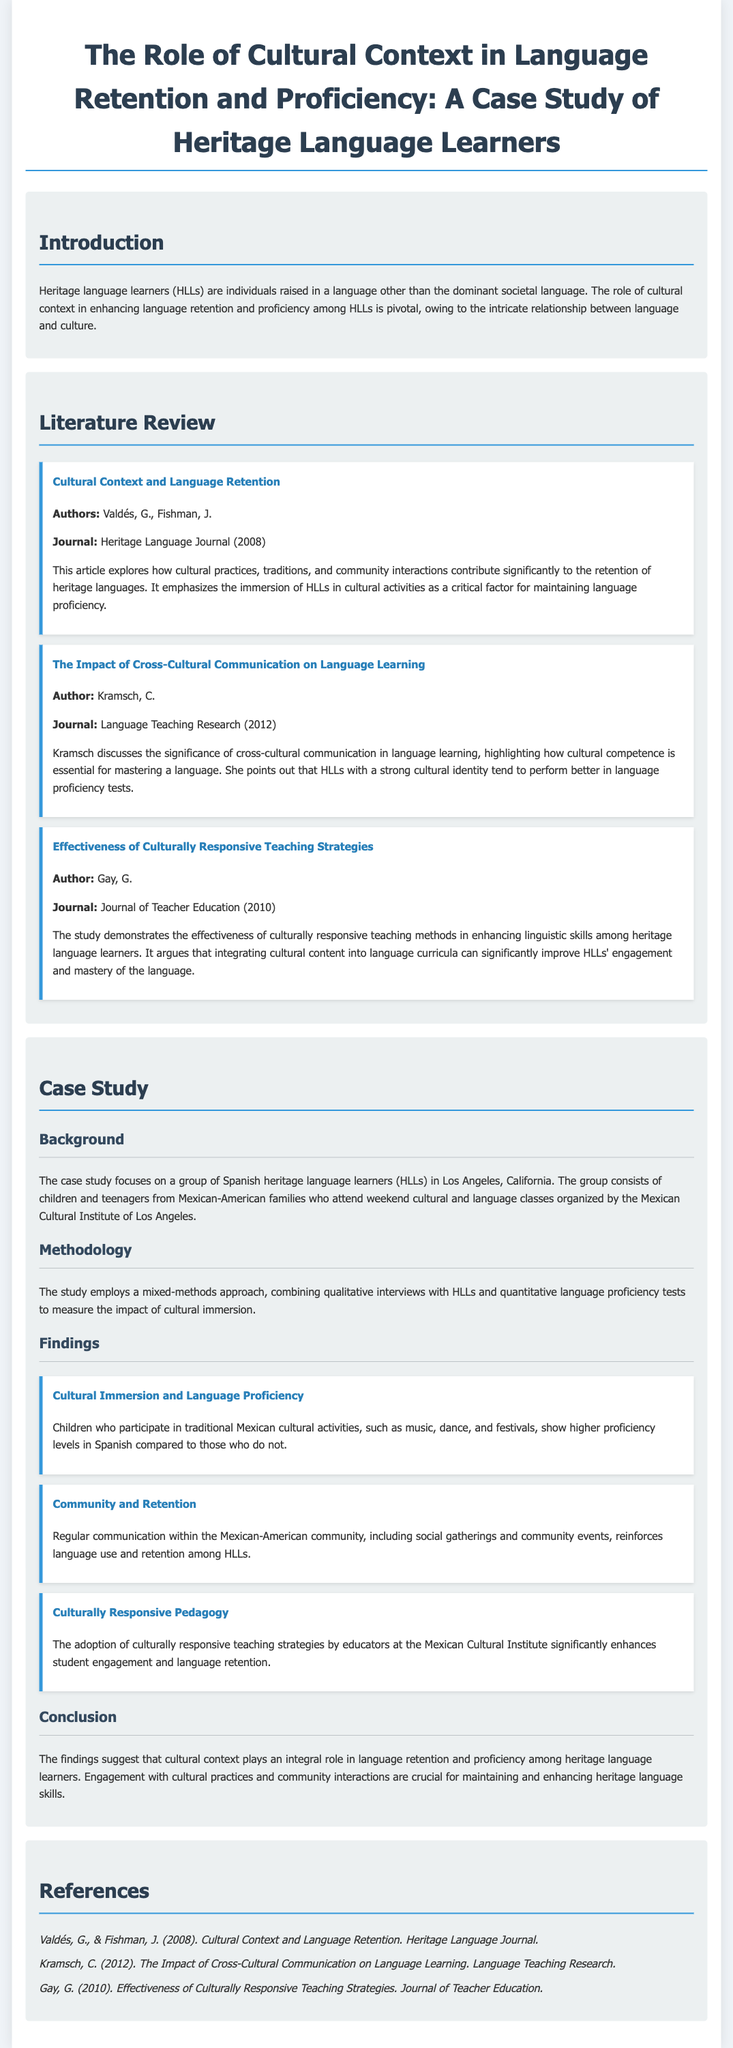What is the focus of the case study? The case study focuses on a group of Spanish heritage language learners in Los Angeles, California.
Answer: Spanish heritage language learners Who are the authors of the literature item about cultural context and language retention? The authors mentioned in the literature review section for this topic are Valdés and Fishman.
Answer: Valdés, G., Fishman, J What teaching strategy is shown to enhance engagement and language retention? The document states that the adoption of culturally responsive teaching strategies enhances student engagement and language retention.
Answer: Culturally responsive teaching strategies In which year was the literature item on the impact of cross-cultural communication published? The year of publication for the literature item discussed is 2012.
Answer: 2012 What is one activity that is linked to higher proficiency levels in Spanish? The case study mentions traditional Mexican cultural activities like music, dance, and festivals as linked to higher proficiency levels.
Answer: Music, dance, and festivals What methodology does the case study employ? The methodology used in the case study combines qualitative interviews and quantitative language proficiency tests.
Answer: Mixed-methods approach How often do the heritage language learners engage with their community? The document discusses regular communication within the Mexican-American community as essential for language use and retention.
Answer: Regular communication What suggestion does the conclusion of the case study emphasize? The conclusion emphasizes that cultural context plays an integral role in language retention and proficiency among heritage language learners.
Answer: Cultural context plays an integral role 